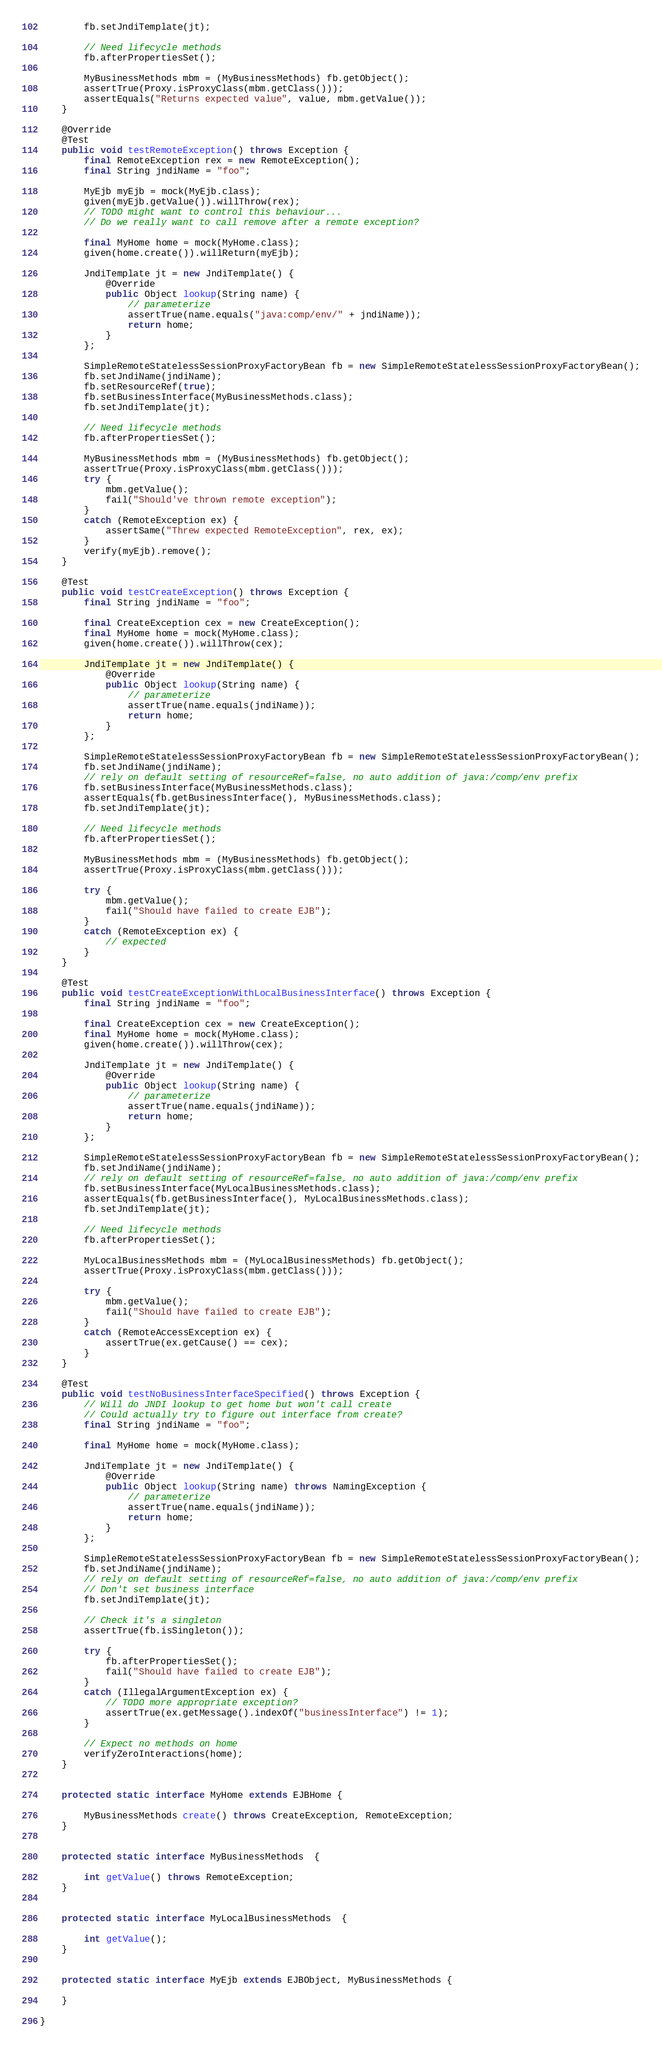<code> <loc_0><loc_0><loc_500><loc_500><_Java_>		fb.setJndiTemplate(jt);

		// Need lifecycle methods
		fb.afterPropertiesSet();

		MyBusinessMethods mbm = (MyBusinessMethods) fb.getObject();
		assertTrue(Proxy.isProxyClass(mbm.getClass()));
		assertEquals("Returns expected value", value, mbm.getValue());
	}

	@Override
	@Test
	public void testRemoteException() throws Exception {
		final RemoteException rex = new RemoteException();
		final String jndiName = "foo";

		MyEjb myEjb = mock(MyEjb.class);
		given(myEjb.getValue()).willThrow(rex);
		// TODO might want to control this behaviour...
		// Do we really want to call remove after a remote exception?

		final MyHome home = mock(MyHome.class);
		given(home.create()).willReturn(myEjb);

		JndiTemplate jt = new JndiTemplate() {
			@Override
			public Object lookup(String name) {
				// parameterize
				assertTrue(name.equals("java:comp/env/" + jndiName));
				return home;
			}
		};

		SimpleRemoteStatelessSessionProxyFactoryBean fb = new SimpleRemoteStatelessSessionProxyFactoryBean();
		fb.setJndiName(jndiName);
		fb.setResourceRef(true);
		fb.setBusinessInterface(MyBusinessMethods.class);
		fb.setJndiTemplate(jt);

		// Need lifecycle methods
		fb.afterPropertiesSet();

		MyBusinessMethods mbm = (MyBusinessMethods) fb.getObject();
		assertTrue(Proxy.isProxyClass(mbm.getClass()));
		try {
			mbm.getValue();
			fail("Should've thrown remote exception");
		}
		catch (RemoteException ex) {
			assertSame("Threw expected RemoteException", rex, ex);
		}
		verify(myEjb).remove();
	}

	@Test
	public void testCreateException() throws Exception {
		final String jndiName = "foo";

		final CreateException cex = new CreateException();
		final MyHome home = mock(MyHome.class);
		given(home.create()).willThrow(cex);

		JndiTemplate jt = new JndiTemplate() {
			@Override
			public Object lookup(String name) {
				// parameterize
				assertTrue(name.equals(jndiName));
				return home;
			}
		};

		SimpleRemoteStatelessSessionProxyFactoryBean fb = new SimpleRemoteStatelessSessionProxyFactoryBean();
		fb.setJndiName(jndiName);
		// rely on default setting of resourceRef=false, no auto addition of java:/comp/env prefix
		fb.setBusinessInterface(MyBusinessMethods.class);
		assertEquals(fb.getBusinessInterface(), MyBusinessMethods.class);
		fb.setJndiTemplate(jt);

		// Need lifecycle methods
		fb.afterPropertiesSet();

		MyBusinessMethods mbm = (MyBusinessMethods) fb.getObject();
		assertTrue(Proxy.isProxyClass(mbm.getClass()));

		try {
			mbm.getValue();
			fail("Should have failed to create EJB");
		}
		catch (RemoteException ex) {
			// expected
		}
	}

	@Test
	public void testCreateExceptionWithLocalBusinessInterface() throws Exception {
		final String jndiName = "foo";

		final CreateException cex = new CreateException();
		final MyHome home = mock(MyHome.class);
		given(home.create()).willThrow(cex);

		JndiTemplate jt = new JndiTemplate() {
			@Override
			public Object lookup(String name) {
				// parameterize
				assertTrue(name.equals(jndiName));
				return home;
			}
		};

		SimpleRemoteStatelessSessionProxyFactoryBean fb = new SimpleRemoteStatelessSessionProxyFactoryBean();
		fb.setJndiName(jndiName);
		// rely on default setting of resourceRef=false, no auto addition of java:/comp/env prefix
		fb.setBusinessInterface(MyLocalBusinessMethods.class);
		assertEquals(fb.getBusinessInterface(), MyLocalBusinessMethods.class);
		fb.setJndiTemplate(jt);

		// Need lifecycle methods
		fb.afterPropertiesSet();

		MyLocalBusinessMethods mbm = (MyLocalBusinessMethods) fb.getObject();
		assertTrue(Proxy.isProxyClass(mbm.getClass()));

		try {
			mbm.getValue();
			fail("Should have failed to create EJB");
		}
		catch (RemoteAccessException ex) {
			assertTrue(ex.getCause() == cex);
		}
	}

	@Test
	public void testNoBusinessInterfaceSpecified() throws Exception {
		// Will do JNDI lookup to get home but won't call create
		// Could actually try to figure out interface from create?
		final String jndiName = "foo";

		final MyHome home = mock(MyHome.class);

		JndiTemplate jt = new JndiTemplate() {
			@Override
			public Object lookup(String name) throws NamingException {
				// parameterize
				assertTrue(name.equals(jndiName));
				return home;
			}
		};

		SimpleRemoteStatelessSessionProxyFactoryBean fb = new SimpleRemoteStatelessSessionProxyFactoryBean();
		fb.setJndiName(jndiName);
		// rely on default setting of resourceRef=false, no auto addition of java:/comp/env prefix
		// Don't set business interface
		fb.setJndiTemplate(jt);

		// Check it's a singleton
		assertTrue(fb.isSingleton());

		try {
			fb.afterPropertiesSet();
			fail("Should have failed to create EJB");
		}
		catch (IllegalArgumentException ex) {
			// TODO more appropriate exception?
			assertTrue(ex.getMessage().indexOf("businessInterface") != 1);
		}

		// Expect no methods on home
		verifyZeroInteractions(home);
	}


	protected static interface MyHome extends EJBHome {

		MyBusinessMethods create() throws CreateException, RemoteException;
	}


	protected static interface MyBusinessMethods  {

		int getValue() throws RemoteException;
	}


	protected static interface MyLocalBusinessMethods  {

		int getValue();
	}


	protected static interface MyEjb extends EJBObject, MyBusinessMethods {

	}

}
</code> 